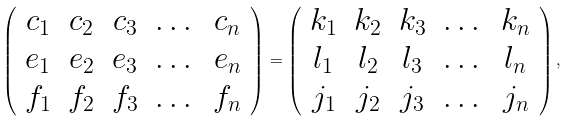<formula> <loc_0><loc_0><loc_500><loc_500>\left ( \begin{array} { c c c c c } c _ { 1 } & c _ { 2 } & c _ { 3 } & \dots & c _ { n } \\ e _ { 1 } & e _ { 2 } & e _ { 3 } & \dots & e _ { n } \\ f _ { 1 } & f _ { 2 } & f _ { 3 } & \dots & f _ { n } \end{array} \right ) = \left ( \begin{array} { c c c c c } k _ { 1 } & k _ { 2 } & k _ { 3 } & \dots & k _ { n } \\ l _ { 1 } & l _ { 2 } & l _ { 3 } & \dots & l _ { n } \\ j _ { 1 } & j _ { 2 } & j _ { 3 } & \dots & j _ { n } \end{array} \right ) ,</formula> 